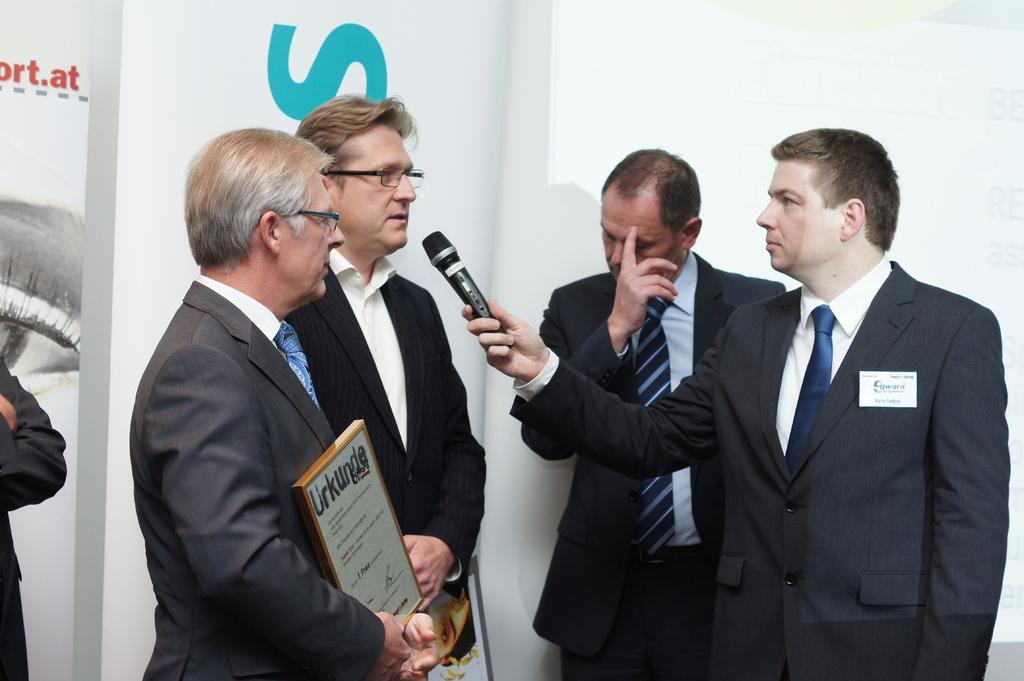Please provide a concise description of this image. In the image we can see there are people who are standing and a person is holding mic in his hand and another person is holding photo frame. 